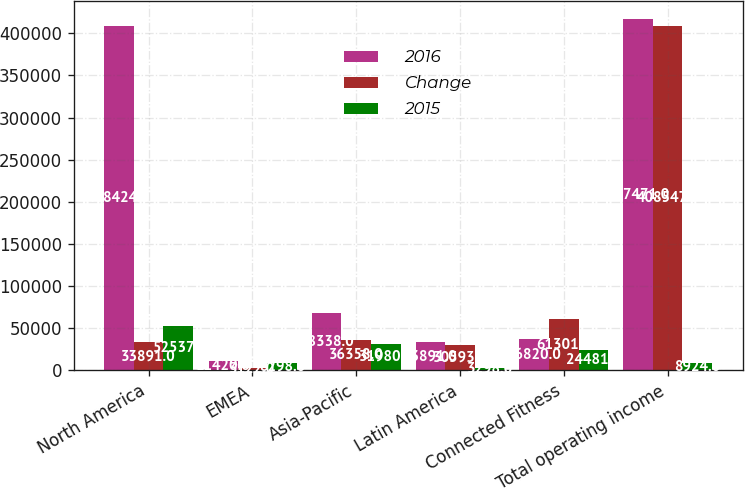Convert chart. <chart><loc_0><loc_0><loc_500><loc_500><stacked_bar_chart><ecel><fcel>North America<fcel>EMEA<fcel>Asia-Pacific<fcel>Latin America<fcel>Connected Fitness<fcel>Total operating income<nl><fcel>2016<fcel>408424<fcel>11420<fcel>68338<fcel>33891<fcel>36820<fcel>417471<nl><fcel>Change<fcel>33891<fcel>3122<fcel>36358<fcel>30593<fcel>61301<fcel>408547<nl><fcel>2015<fcel>52537<fcel>8298<fcel>31980<fcel>3298<fcel>24481<fcel>8924<nl></chart> 